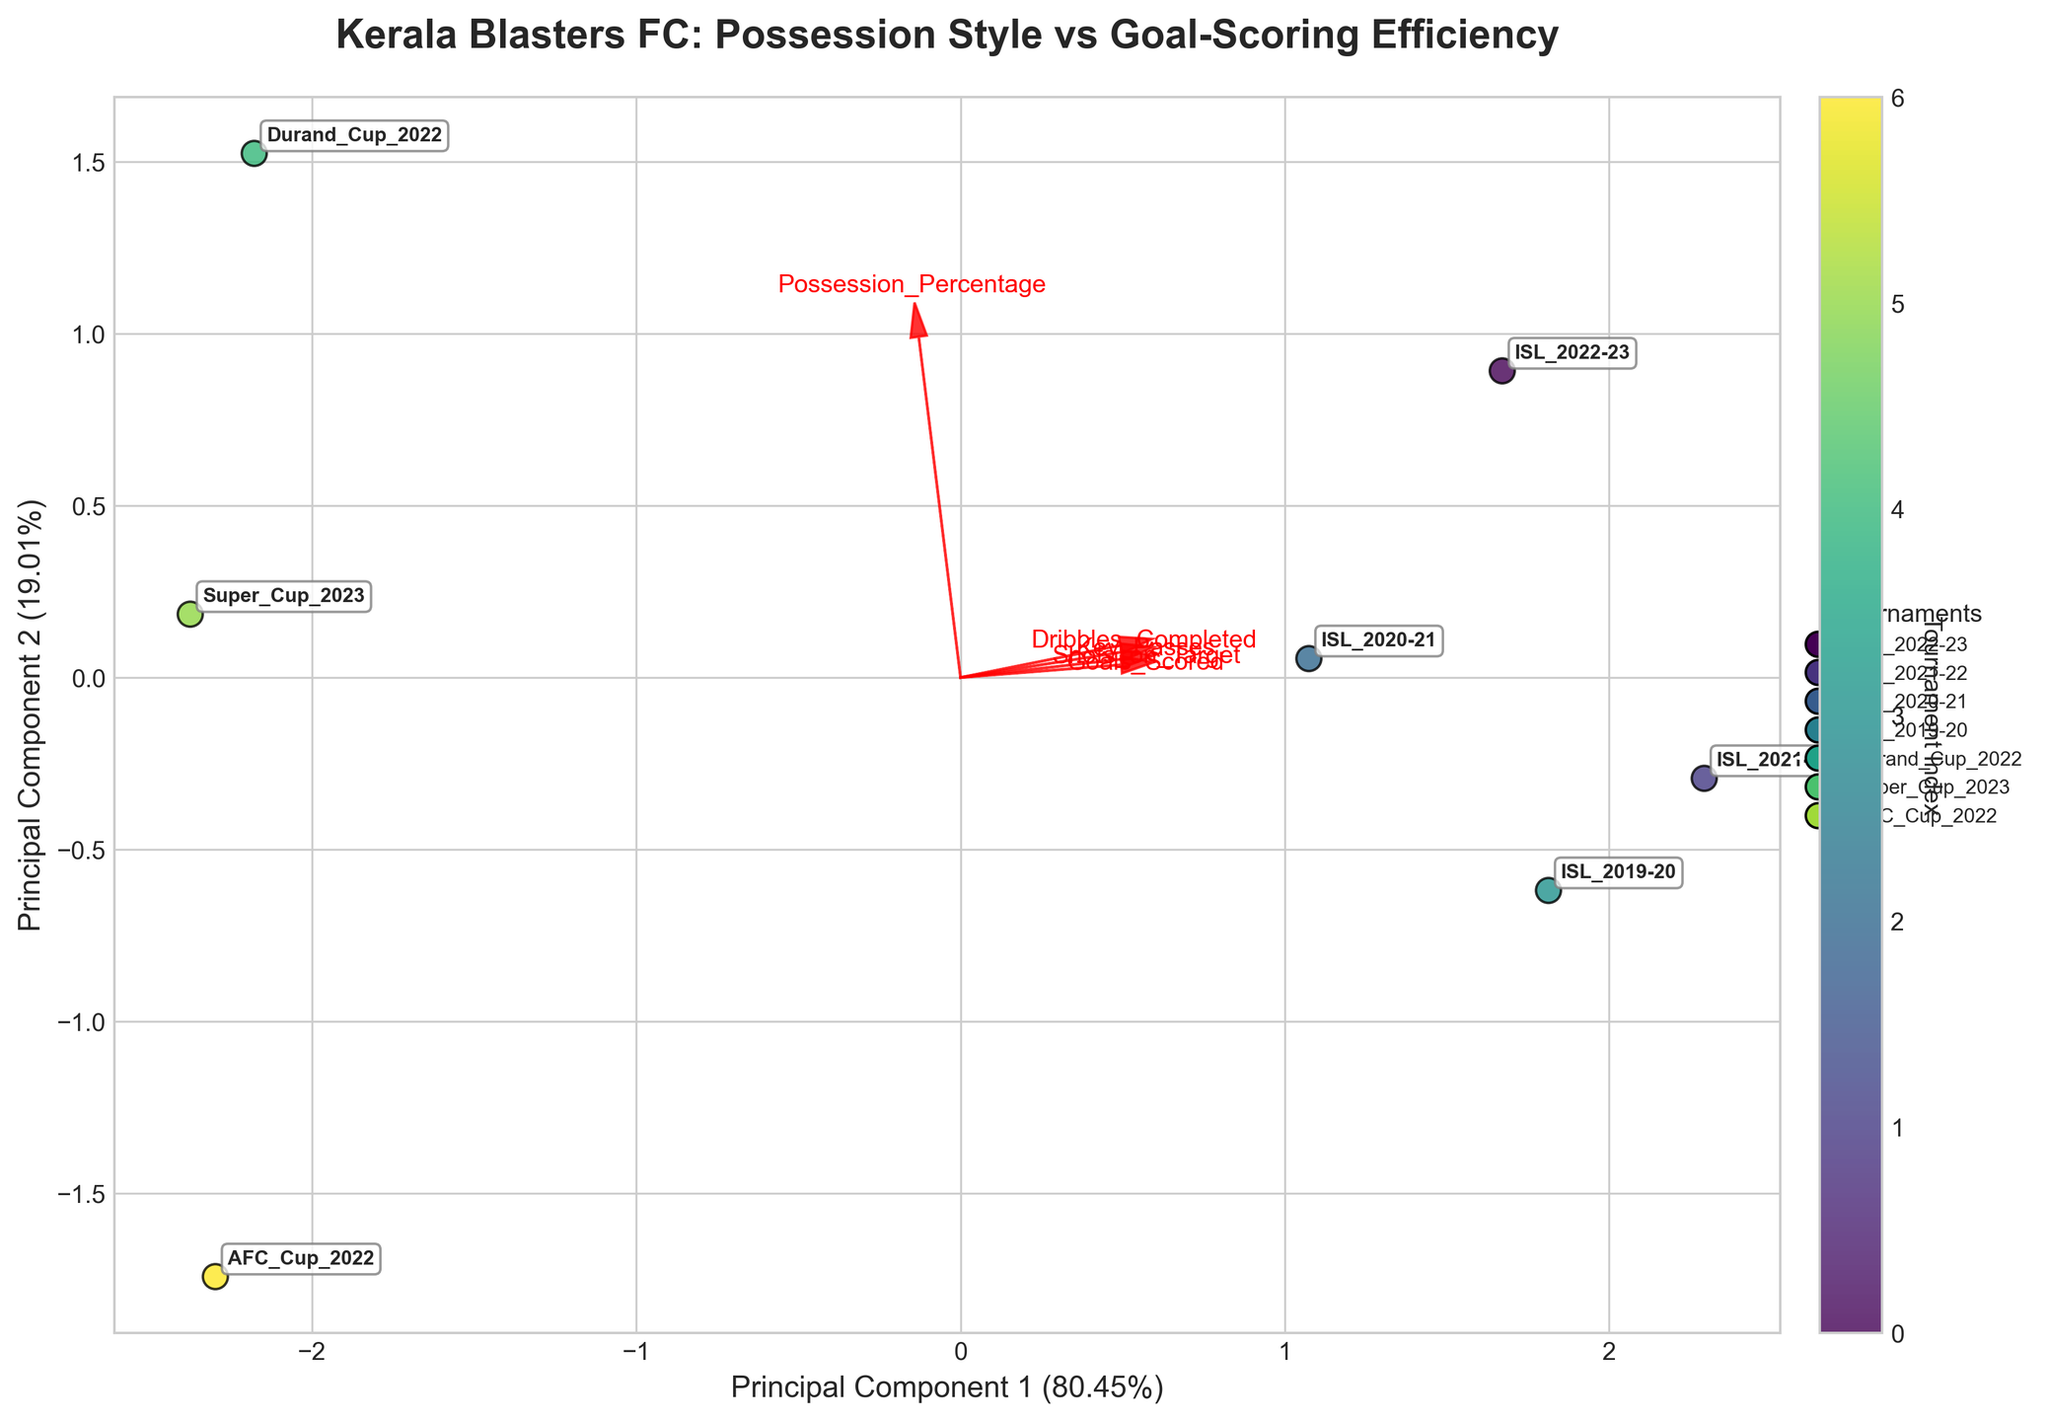What is the title of the biplot? The title is located at the top of the plot and provides a summary of the chart's content.
Answer: "Kerala Blasters FC: Possession Style vs Goal-Scoring Efficiency" Which tournament's data point is closest to the origin (0,0) of the PCA plot? You can identify the data point closest to (0,0) by visually inspecting the plot and looking at the tournament labels.
Answer: AFC Cup 2022 Which vector represents the 'Goals Scored' feature in the biplot? In the biplot, feature vectors are represented by arrows. Look for the arrow labeled 'Goals Scored'.
Answer: The arrow labeled 'Goals Scored' Which tournament has the highest possessive style according to the biplot? The possession percentage is one of the variables plotted. The tournament with a data point furthest in the direction of the 'Possession_Percentage' vector has the highest possessive style.
Answer: Durand Cup 2022 How many variables are shown as vectors in the biplot? Count the number of arrows (feature vectors) originating from the origin.
Answer: 5 Compare the goal-scoring efficiency between ISL 2022-23 and ISL 2021-22. Which tournament is more efficient? Goal-scoring efficiency can be inferred by observing the 'Goals Scored' vector's direction and examining the positions of the ISL 2022-23 and ISL 2021-22 data points relative to this vector.
Answer: ISL 2021-22 What percentage of the total variance is explained by the first principal component in the plot? The variance explained by the principal components is usually indicated in the axis labels. Check the label of the x-axis.
Answer: 50.00% How do the shots on target compare between ISL 2020-21 and Super Cup 2023 according to the biplot? Compare the relative positions of the ISL 2020-21 and Super Cup 2023 data points along the direction of the 'Shots_on_Target' vector.
Answer: ISL 2020-21 has higher shots on target Which tournament is most closely associated with both high key passes and dribbles completed? Observe the directions of the 'Key_Passes' and 'Dribbles_Completed' vectors and identify the tournament data point closest to the resulting direction formed by these two vectors.
Answer: ISL 2021-22 